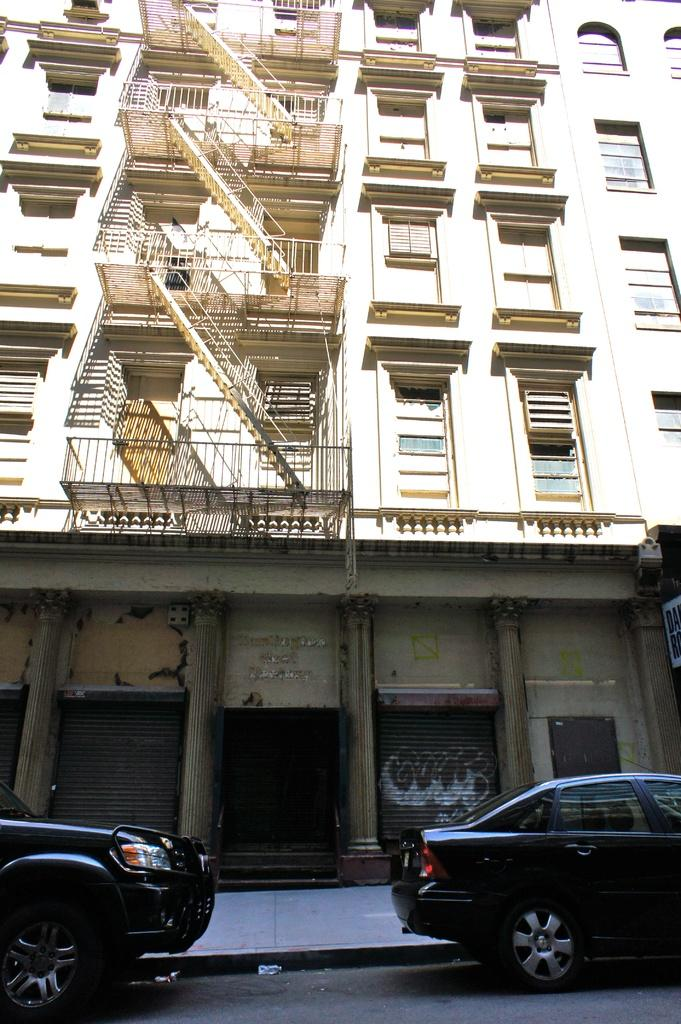What is the main subject in the center of the image? There is a building in the center of the image. What can be seen near the building? There are railings in the image. What is happening at the bottom of the image? Vehicles are present on the road at the bottom of the image. What type of sea creature can be seen swimming near the building in the image? There is no sea creature present in the image, as it features a building and vehicles on a road. 